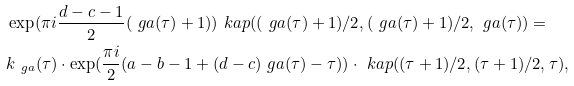<formula> <loc_0><loc_0><loc_500><loc_500>& \exp ( \pi i \frac { d - c - 1 } { 2 } ( \ g a ( \tau ) + 1 ) ) \ k a p ( ( \ g a ( \tau ) + 1 ) / 2 , ( \ g a ( \tau ) + 1 ) / 2 , \ g a ( \tau ) ) = \\ & k _ { \ g a } ( \tau ) \cdot \exp ( \frac { \pi i } { 2 } ( a - b - 1 + ( d - c ) \ g a ( \tau ) - \tau ) ) \cdot \ k a p ( ( \tau + 1 ) / 2 , ( \tau + 1 ) / 2 , \tau ) ,</formula> 